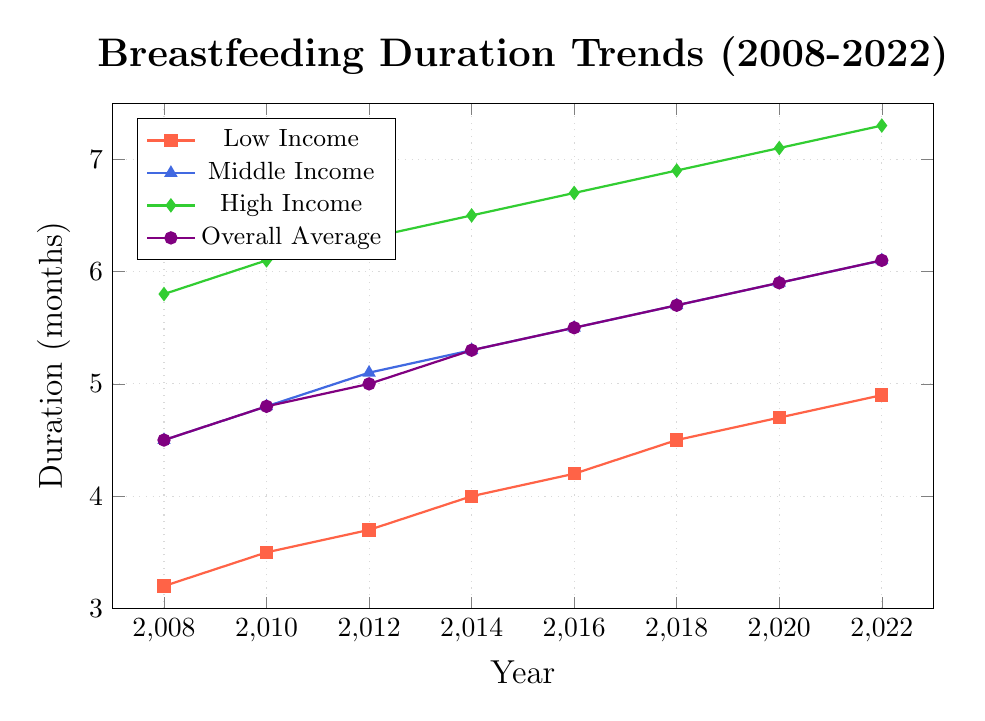What is the general trend of breastfeeding duration among new mothers from 2008 to 2022? The overall average breastfeeding duration has increased over time from 4.5 months in 2008 to 6.1 months in 2022.
Answer: Increase Which socioeconomic group has the highest breastfeeding duration in 2022? In 2022, the high-income group has the highest breastfeeding duration at 7.3 months.
Answer: High Income By how many months has the breastfeeding duration increased for the low-income group from 2008 to 2022? In 2008, the duration for the low-income group was 3.2 months, and in 2022 it is 4.9 months. The increase over 14 years (2022 - 2008) is 4.9 - 3.2 = 1.7 months.
Answer: 1.7 months What is the difference in breastfeeding duration between the high-income and low-income groups in 2014? In 2014, the high-income group has a duration of 6.5 months while the low-income group has 4.0 months. The difference is 6.5 - 4.0 = 2.5 months.
Answer: 2.5 months What is the average breastfeeding duration across all socioeconomic groups in 2016? The overall average breastfeeding duration in 2016 is shown to be 5.5 months.
Answer: 5.5 months Has the middle-income group’s breastfeeding duration ever surpassed 6 months over the past 15 years? The middle-income group's breastfeeding duration reached 6.1 months in 2022.
Answer: Yes What is the ratio of the breastfeeding duration of the high-income group to the overall average in 2018? In 2018, the high-income group has a breastfeeding duration of 6.9 months, and the overall average is 5.7 months. The ratio is 6.9 / 5.7. Simplified, this ratio is approximately 1.21.
Answer: 1.21 Between which consecutive years did the low-income group see the greatest increase in breastfeeding duration? The low-income group saw an increase from 3.7 months in 2012 to 4.0 months in 2014, an increase of 0.3 months. This increase of 0.3 months is also seen between 2016 and 2018. Thus, 2012 to 2014 and 2016 to 2018 both saw an increase of 0.3 months.
Answer: 2012 to 2014, 2016 to 2018 Which color represents the middle-income group on the line chart? The middle-income group is represented by the color blue.
Answer: Blue 